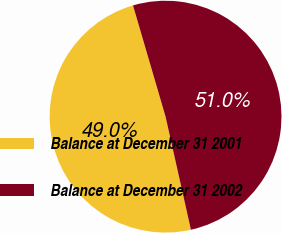<chart> <loc_0><loc_0><loc_500><loc_500><pie_chart><fcel>Balance at December 31 2001<fcel>Balance at December 31 2002<nl><fcel>48.98%<fcel>51.02%<nl></chart> 